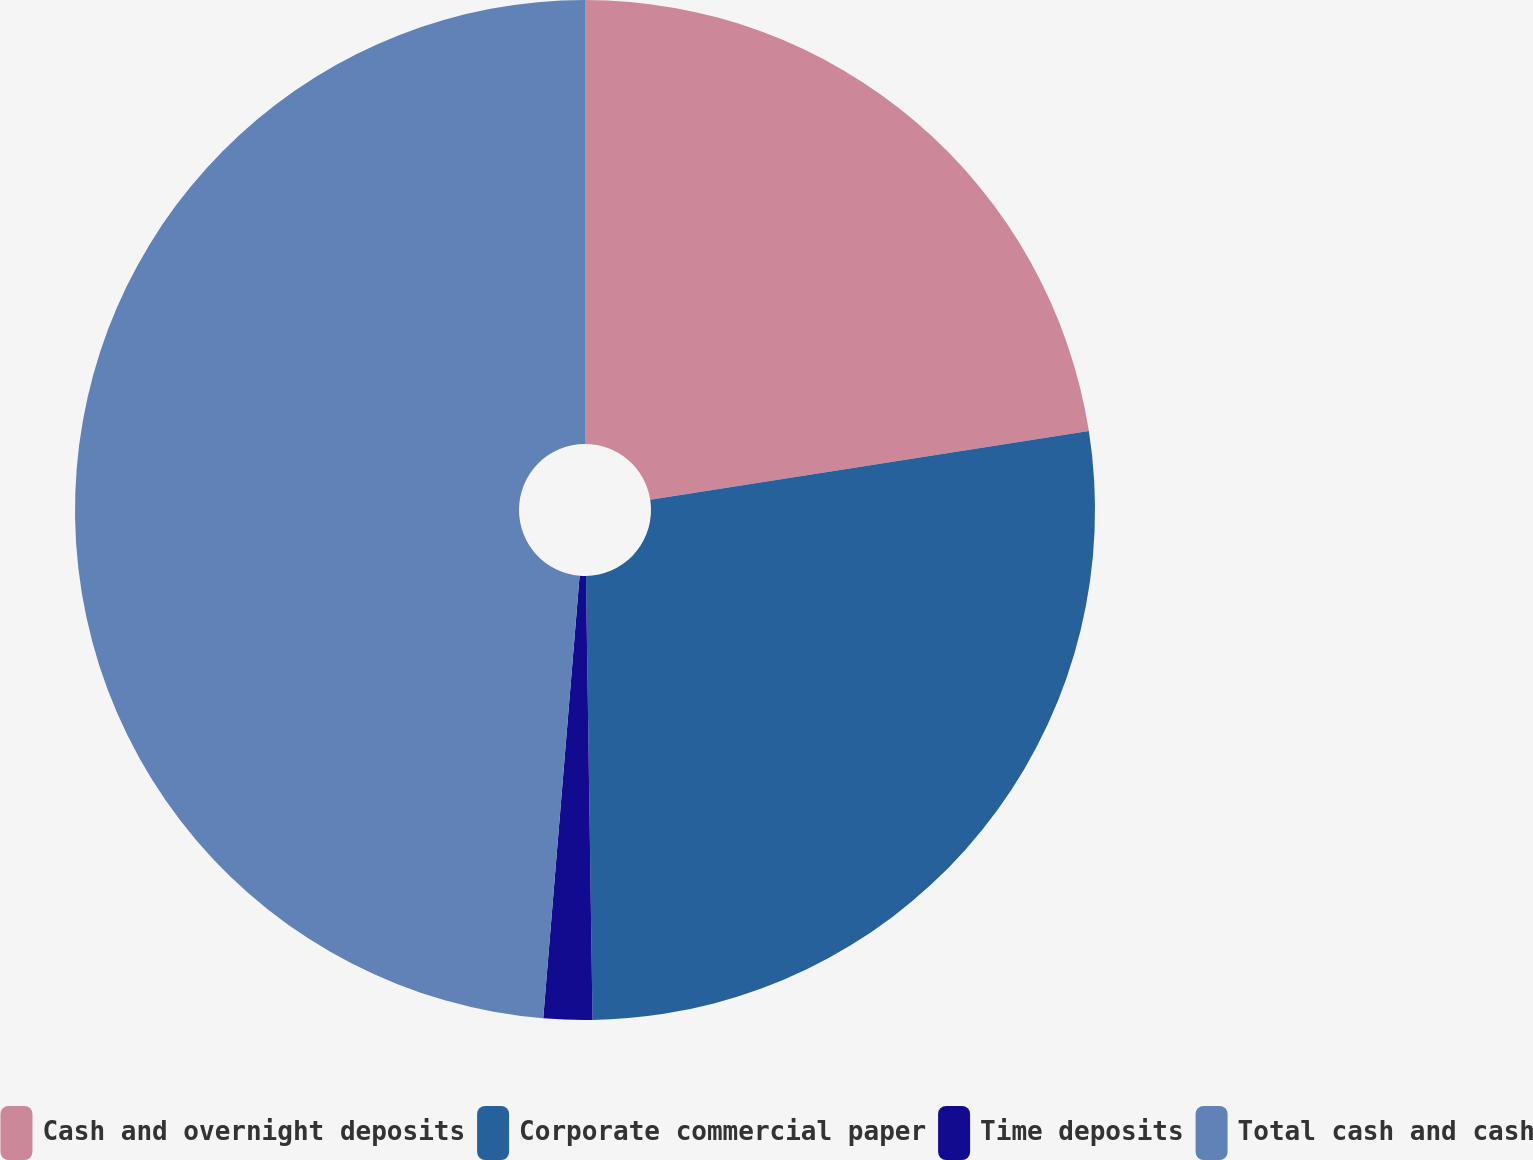Convert chart to OTSL. <chart><loc_0><loc_0><loc_500><loc_500><pie_chart><fcel>Cash and overnight deposits<fcel>Corporate commercial paper<fcel>Time deposits<fcel>Total cash and cash<nl><fcel>22.53%<fcel>27.24%<fcel>1.54%<fcel>48.7%<nl></chart> 